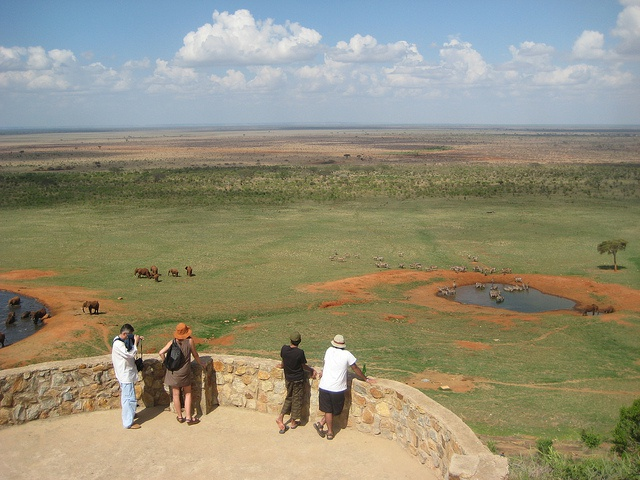Describe the objects in this image and their specific colors. I can see people in gray, white, and black tones, elephant in gray and olive tones, people in gray, lightgray, darkgray, and black tones, people in gray and black tones, and people in gray and maroon tones in this image. 